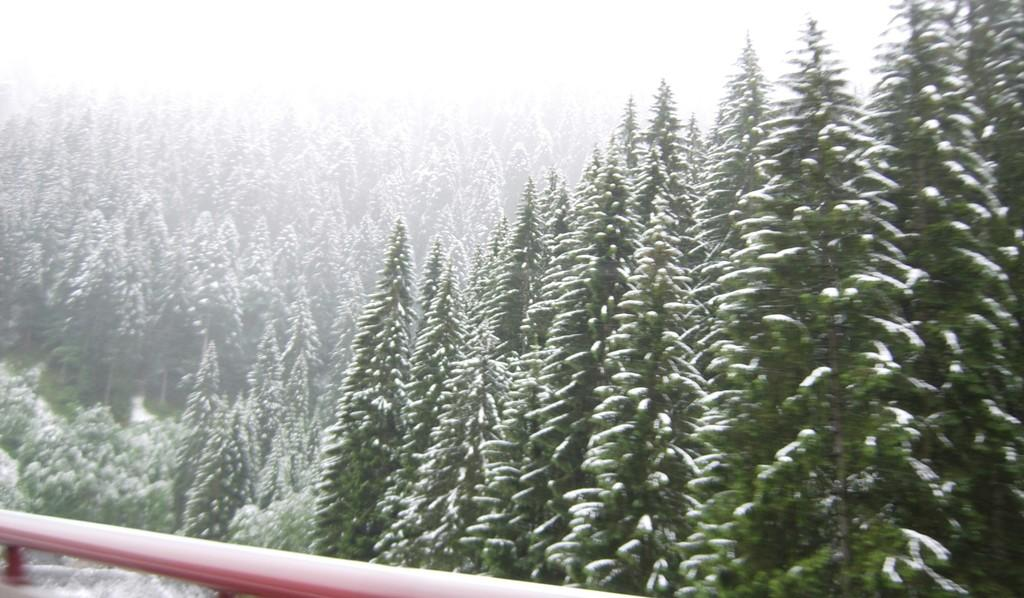What type of natural vegetation is present in the image? There is a group of trees in the image. Can you describe any other objects or features in the image? There is a rod at the bottom of the image. How many rabbits can be seen playing with a degree in the image? There are no rabbits or degrees present in the image. What type of glue is used to hold the trees together in the image? There is no glue used to hold the trees together in the image, as they are naturally growing plants. 